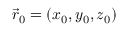<formula> <loc_0><loc_0><loc_500><loc_500>\vec { r } _ { 0 } = ( x _ { 0 } , y _ { 0 } , z _ { 0 } )</formula> 